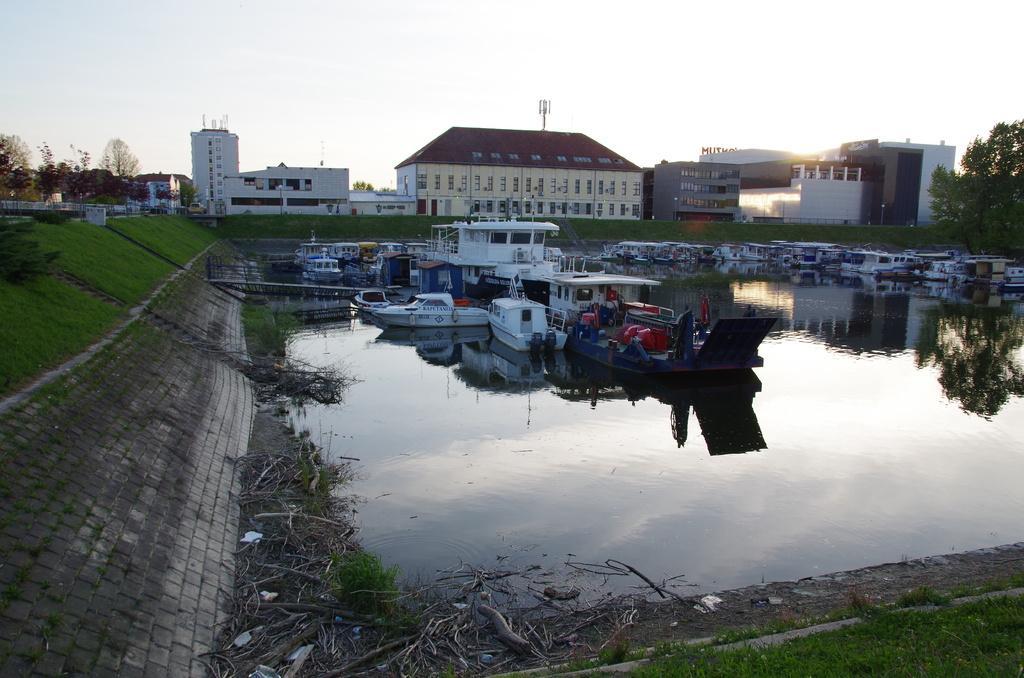Can you describe this image briefly? In this image there are a few boats and ships on the water, around the water there are some wooden sticks, plants and grass. In the background there are buildings, trees and the sky. 